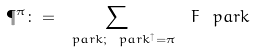<formula> <loc_0><loc_0><loc_500><loc_500>\P ^ { \pi } \colon = \sum _ { \ p a r k ; \ p a r k ^ { \uparrow } = \pi } { \ F _ { \ } p a r k }</formula> 